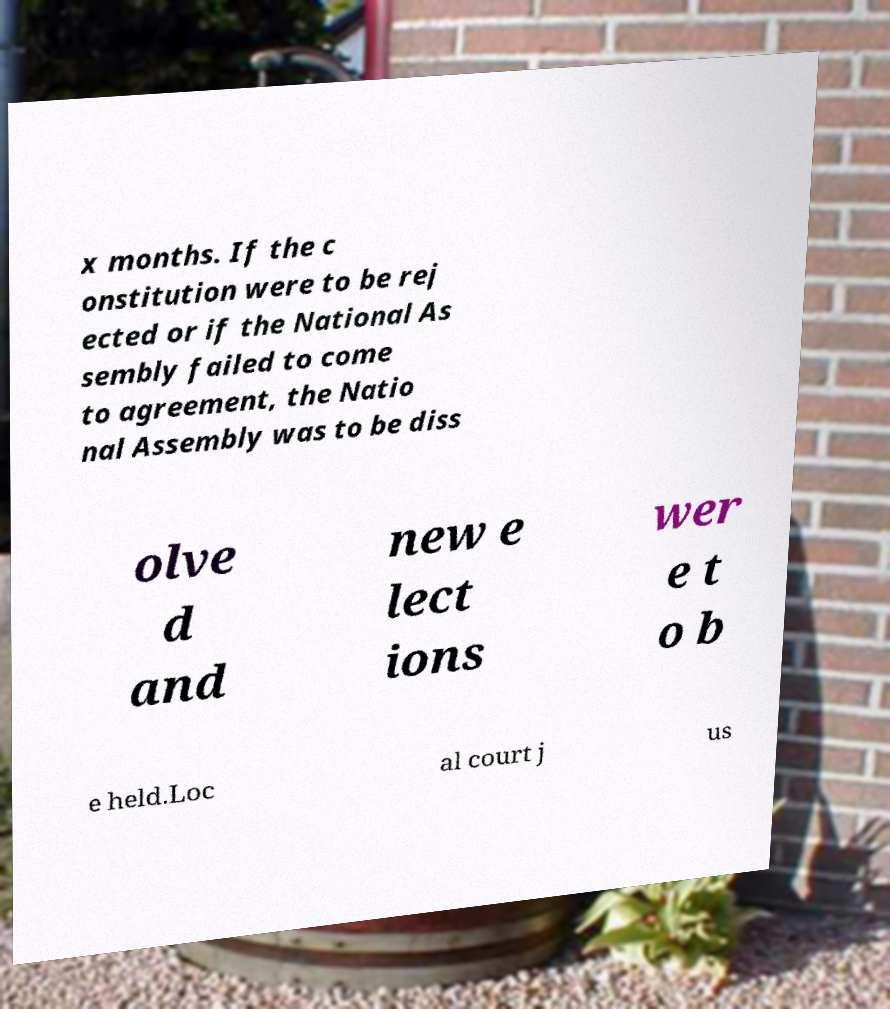Please read and relay the text visible in this image. What does it say? x months. If the c onstitution were to be rej ected or if the National As sembly failed to come to agreement, the Natio nal Assembly was to be diss olve d and new e lect ions wer e t o b e held.Loc al court j us 